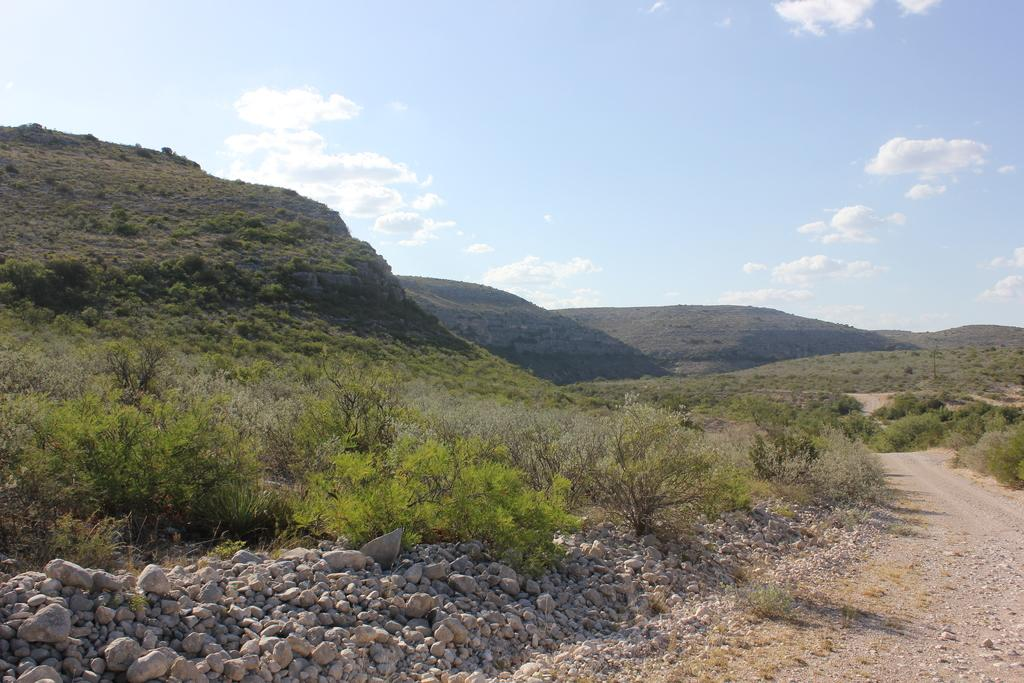What type of road is visible in the image? There is a road made of soil in the image. What other natural elements can be seen in the image? There are stones, rocks, plants, and trees visible in the image. What is the background of the image? There are mountains in the background of the image. How are the mountains covered? The mountains are covered with trees. Can you see a pan being used to cook food in the image? There is no pan or cooking activity visible in the image. How many toes are visible on the trees in the image? Trees do not have toes, so this question is not applicable to the image. 